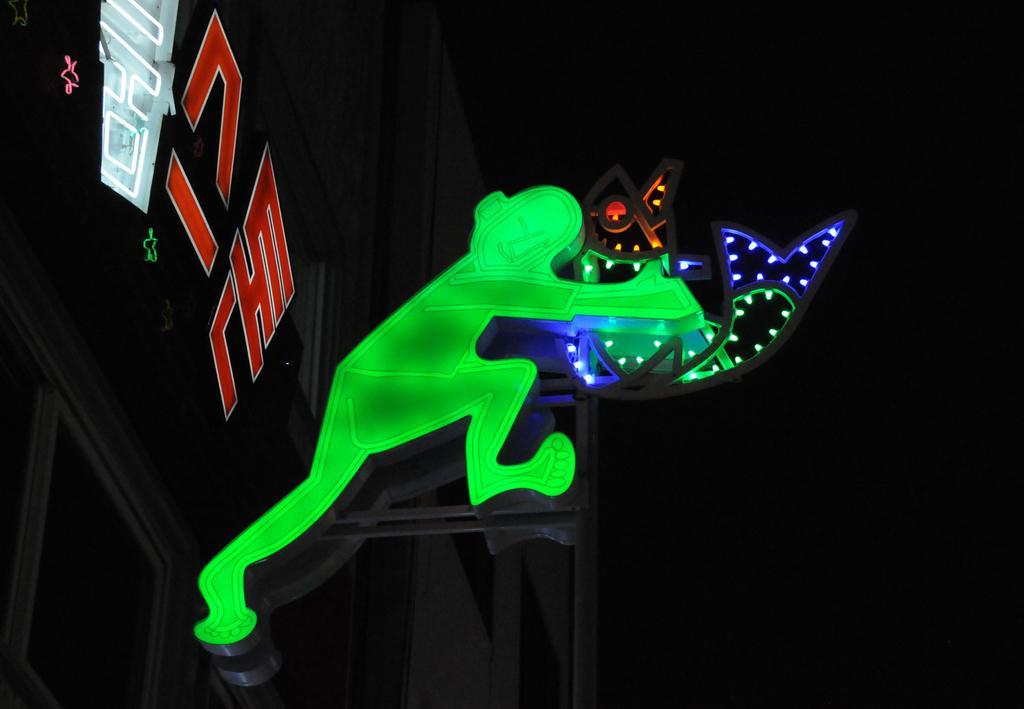Can you describe this image briefly? In this image there is a building. At front of the building there is a person holding the object. 